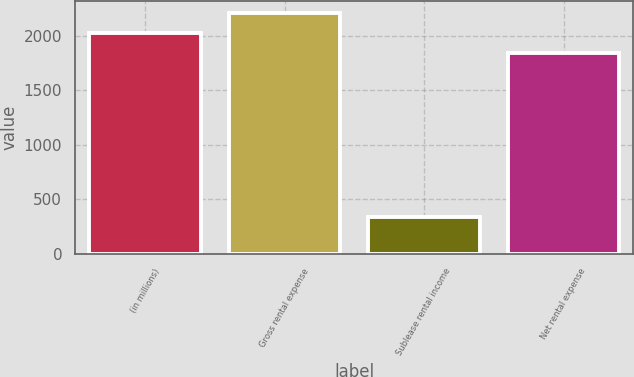<chart> <loc_0><loc_0><loc_500><loc_500><bar_chart><fcel>(in millions)<fcel>Gross rental expense<fcel>Sublease rental income<fcel>Net rental expense<nl><fcel>2030.6<fcel>2215.2<fcel>341<fcel>1846<nl></chart> 